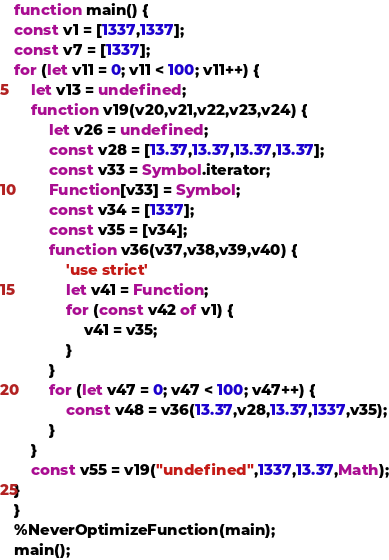<code> <loc_0><loc_0><loc_500><loc_500><_JavaScript_>function main() {
const v1 = [1337,1337];
const v7 = [1337];
for (let v11 = 0; v11 < 100; v11++) {
    let v13 = undefined;
    function v19(v20,v21,v22,v23,v24) {
        let v26 = undefined;
        const v28 = [13.37,13.37,13.37,13.37];
        const v33 = Symbol.iterator;
        Function[v33] = Symbol;
        const v34 = [1337];
        const v35 = [v34];
        function v36(v37,v38,v39,v40) {
            'use strict'
            let v41 = Function;
            for (const v42 of v1) {
                v41 = v35;
            }
        }
        for (let v47 = 0; v47 < 100; v47++) {
            const v48 = v36(13.37,v28,13.37,1337,v35);
        }
    }
    const v55 = v19("undefined",1337,13.37,Math);
}
}
%NeverOptimizeFunction(main);
main();
</code> 